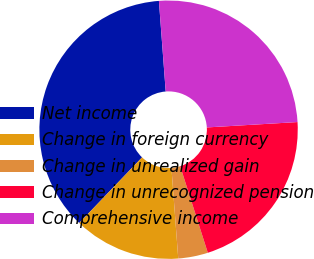Convert chart. <chart><loc_0><loc_0><loc_500><loc_500><pie_chart><fcel>Net income<fcel>Change in foreign currency<fcel>Change in unrealized gain<fcel>Change in unrecognized pension<fcel>Comprehensive income<nl><fcel>36.65%<fcel>13.35%<fcel>3.72%<fcel>21.03%<fcel>25.25%<nl></chart> 